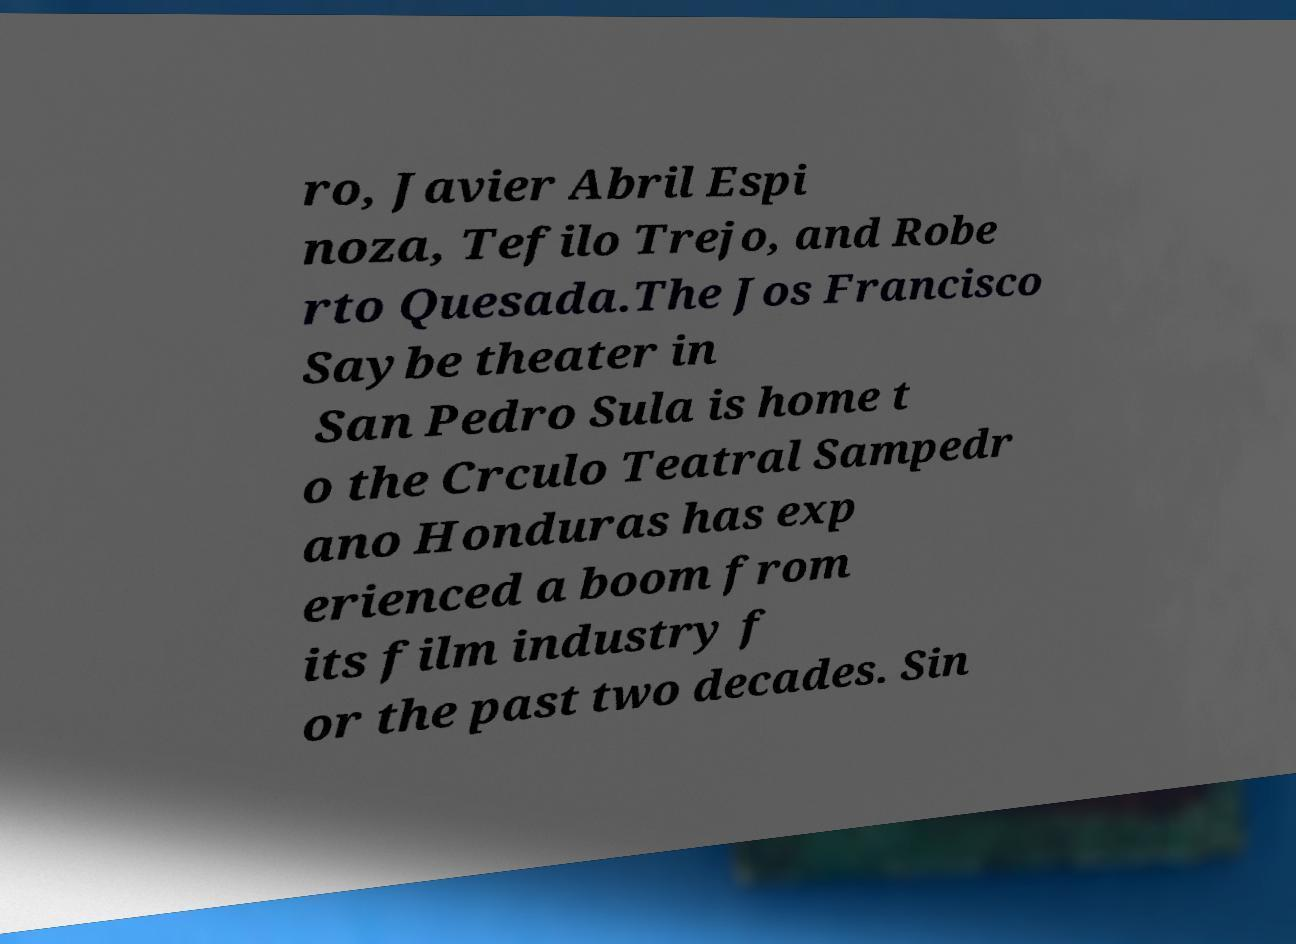Could you extract and type out the text from this image? ro, Javier Abril Espi noza, Tefilo Trejo, and Robe rto Quesada.The Jos Francisco Saybe theater in San Pedro Sula is home t o the Crculo Teatral Sampedr ano Honduras has exp erienced a boom from its film industry f or the past two decades. Sin 